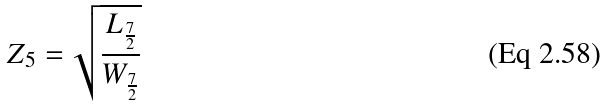Convert formula to latex. <formula><loc_0><loc_0><loc_500><loc_500>Z _ { 5 } = \sqrt { \frac { L _ { \frac { 7 } { 2 } } } { W _ { \frac { 7 } { 2 } } } }</formula> 